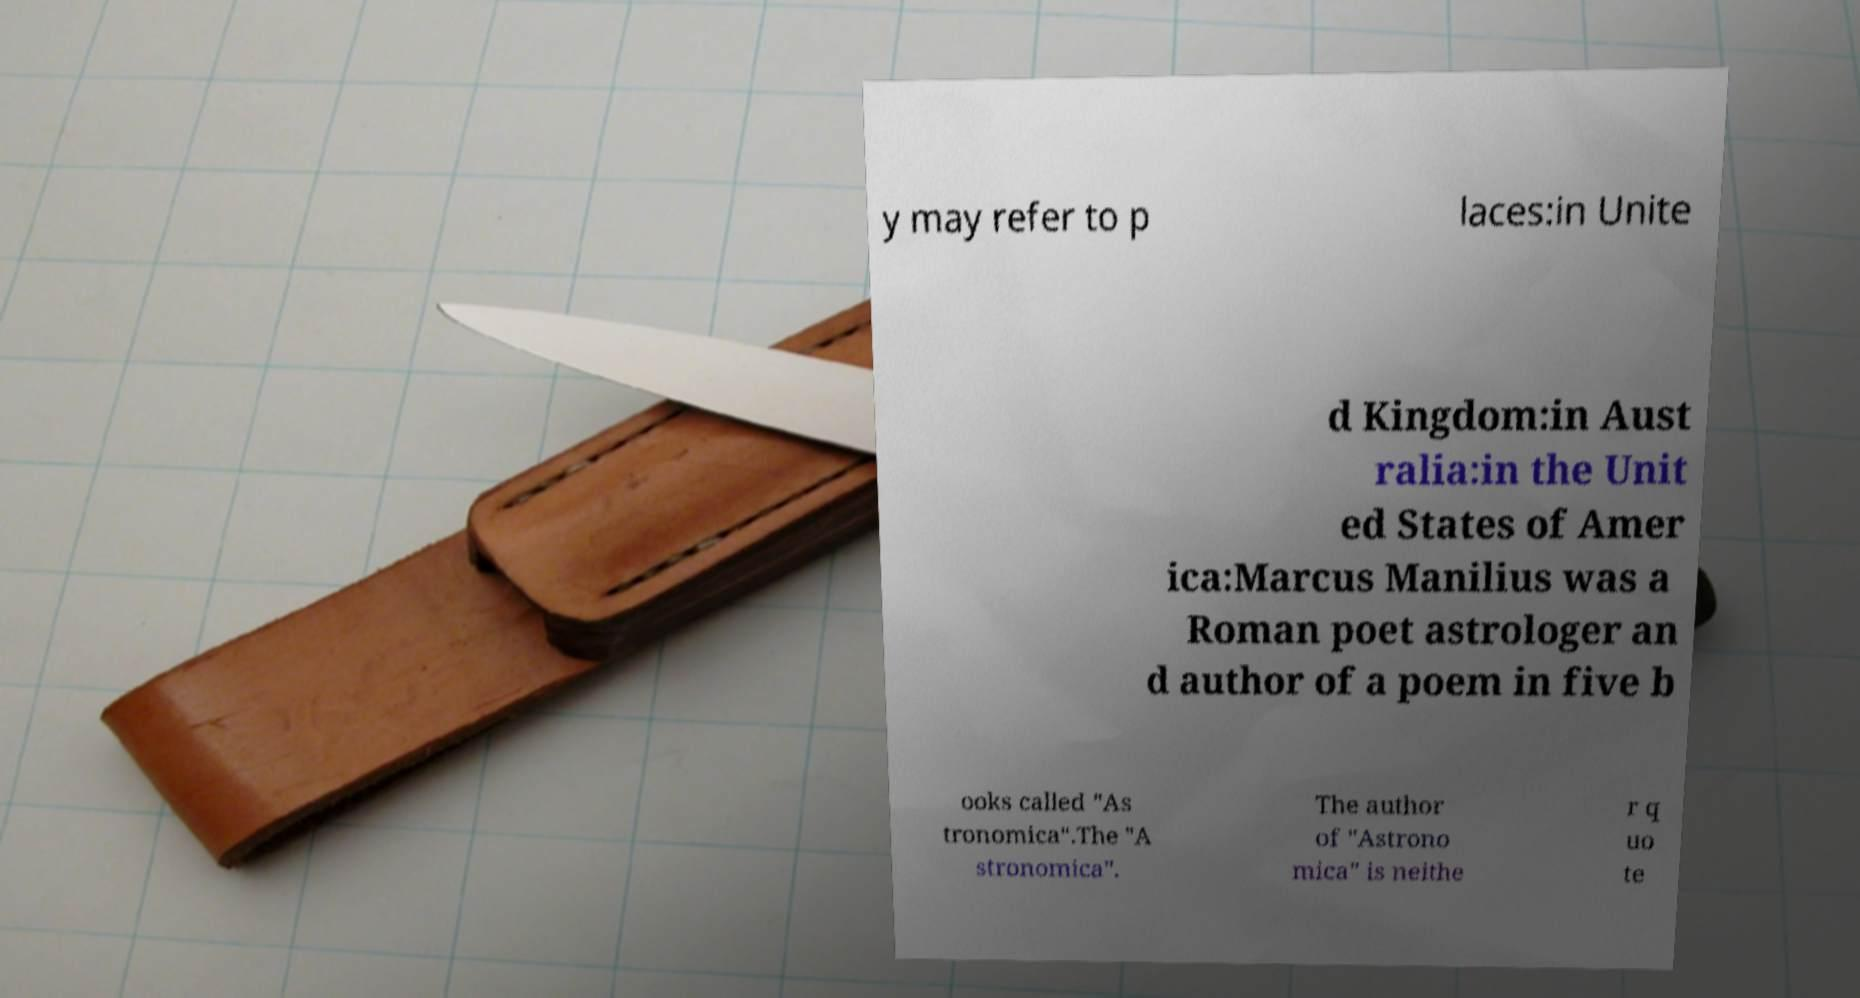Could you extract and type out the text from this image? y may refer to p laces:in Unite d Kingdom:in Aust ralia:in the Unit ed States of Amer ica:Marcus Manilius was a Roman poet astrologer an d author of a poem in five b ooks called "As tronomica".The "A stronomica". The author of "Astrono mica" is neithe r q uo te 